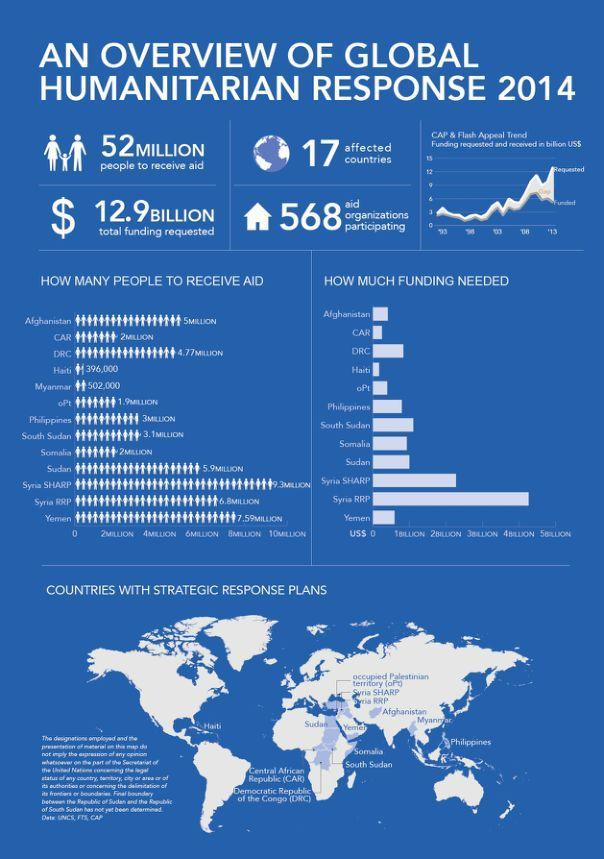How many aid organizations are participating in the Global Humanitarian Response 2014?
Answer the question with a short phrase. 568 How many people will receive aid in Myanmar as per the Global Humanitarian Response 2014? 502,000 How many people will receive aid in Somalia as per the Global Humanitarian Response 2014? 2 MILLION 